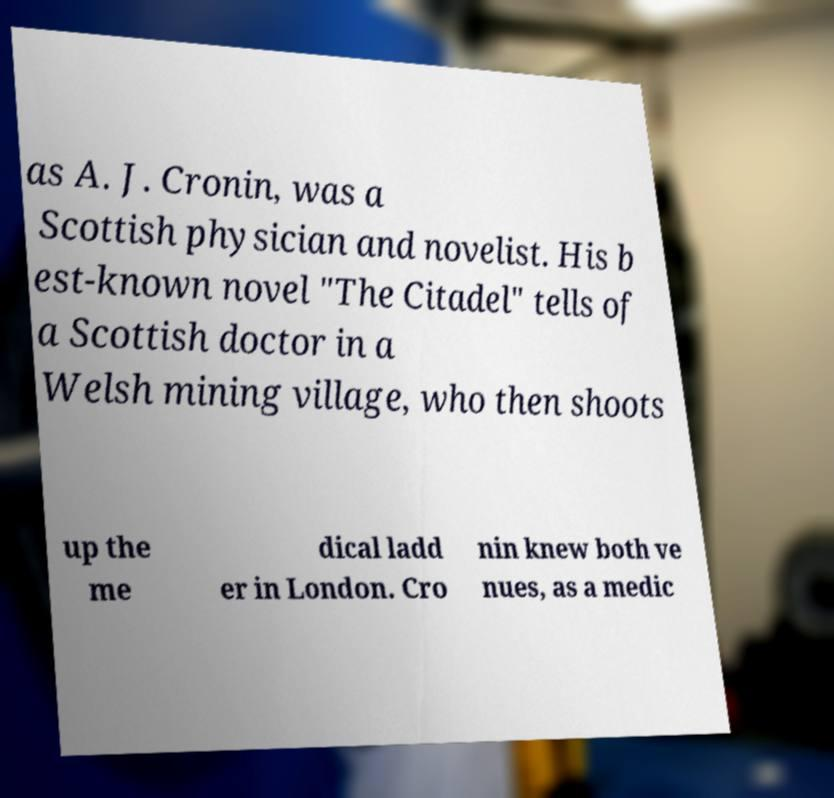Could you assist in decoding the text presented in this image and type it out clearly? as A. J. Cronin, was a Scottish physician and novelist. His b est-known novel "The Citadel" tells of a Scottish doctor in a Welsh mining village, who then shoots up the me dical ladd er in London. Cro nin knew both ve nues, as a medic 